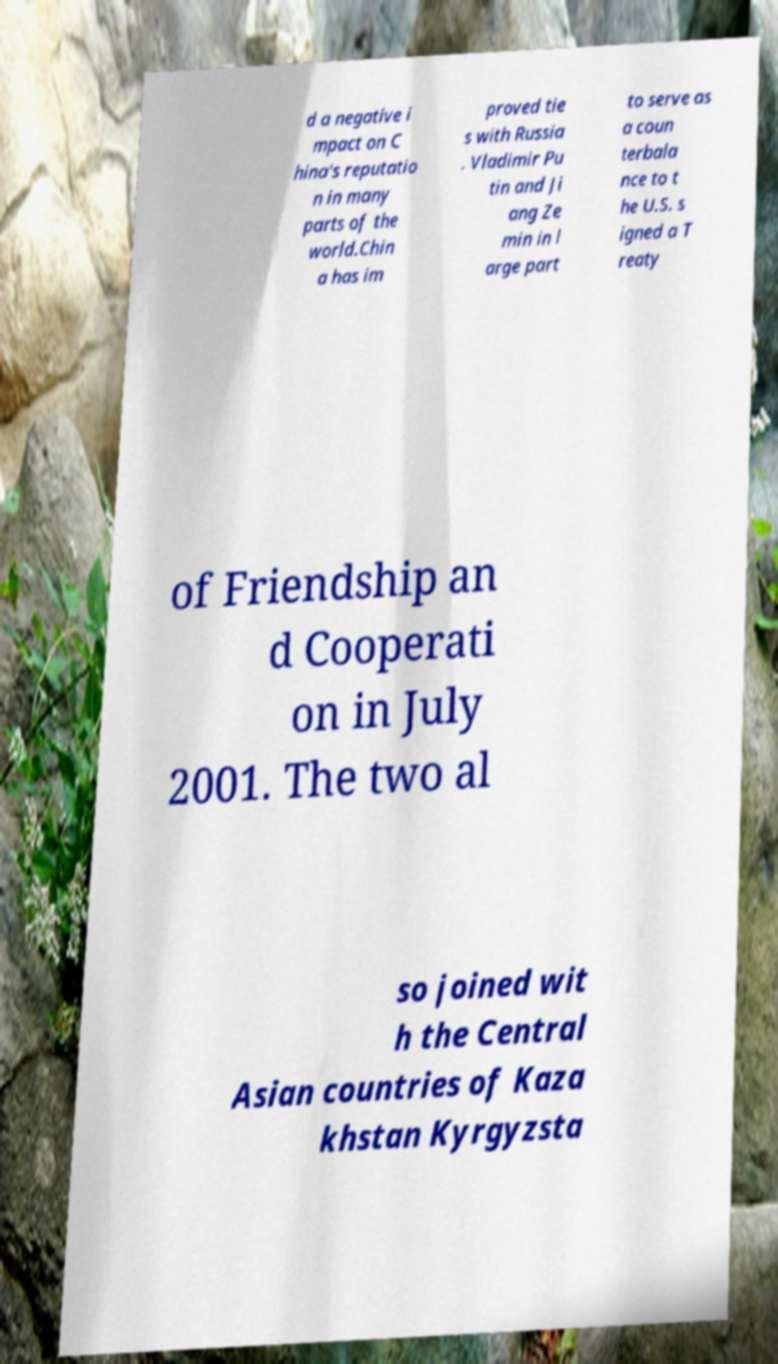Could you extract and type out the text from this image? d a negative i mpact on C hina's reputatio n in many parts of the world.Chin a has im proved tie s with Russia . Vladimir Pu tin and Ji ang Ze min in l arge part to serve as a coun terbala nce to t he U.S. s igned a T reaty of Friendship an d Cooperati on in July 2001. The two al so joined wit h the Central Asian countries of Kaza khstan Kyrgyzsta 